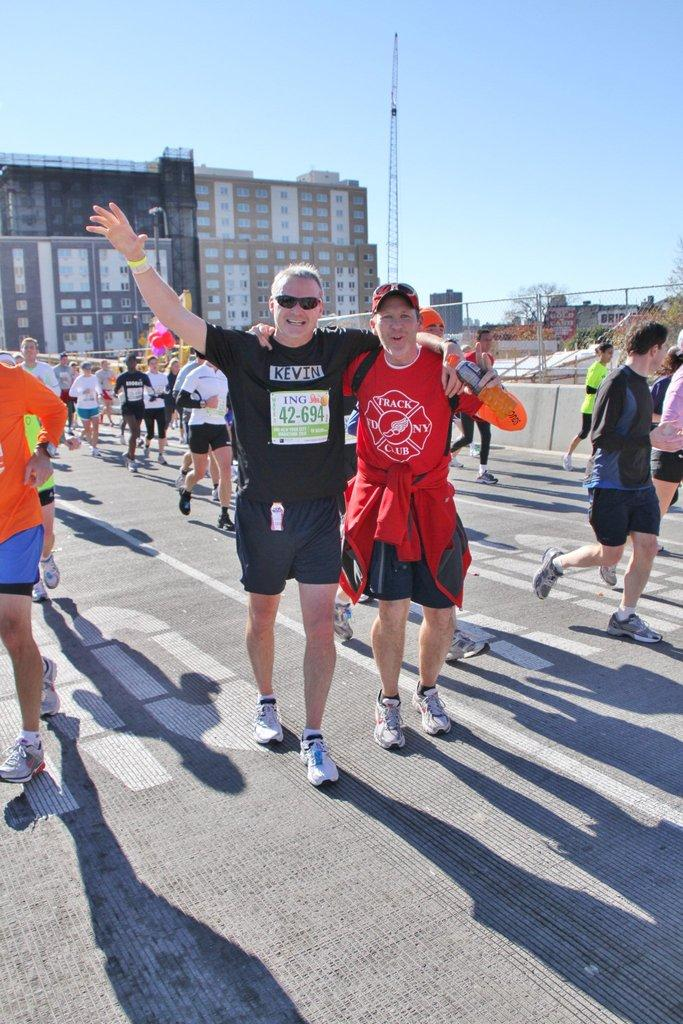How many people are in the image? There is a group of people in the image, but the exact number cannot be determined from the provided facts. What are the people in the image doing? Some people are running, while others are walking. What can be seen in the foreground of the image? There is a road in the image. What is visible in the background of the image? There is a fence, trees, buildings with windows, and the sky visible in the background of the image. What type of pencil can be seen in the hands of the people in the image? There is no pencil present in the image; the people are running and walking, not drawing or writing. 